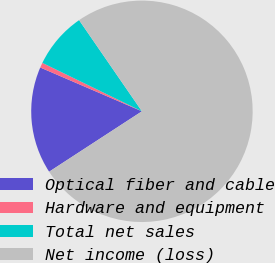Convert chart. <chart><loc_0><loc_0><loc_500><loc_500><pie_chart><fcel>Optical fiber and cable<fcel>Hardware and equipment<fcel>Total net sales<fcel>Net income (loss)<nl><fcel>15.66%<fcel>0.73%<fcel>8.19%<fcel>75.42%<nl></chart> 